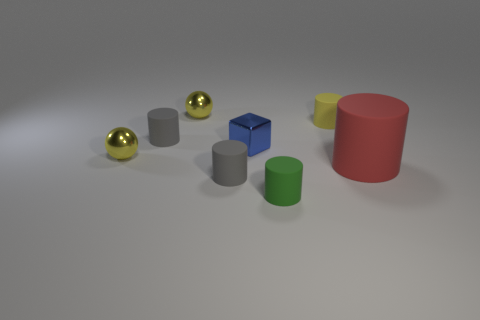Can you tell me which objects in the image are reflecting the light most? The objects reflecting light the most are the three gold spheres; they have a shiny surface that reflects the light, making them stand out. 